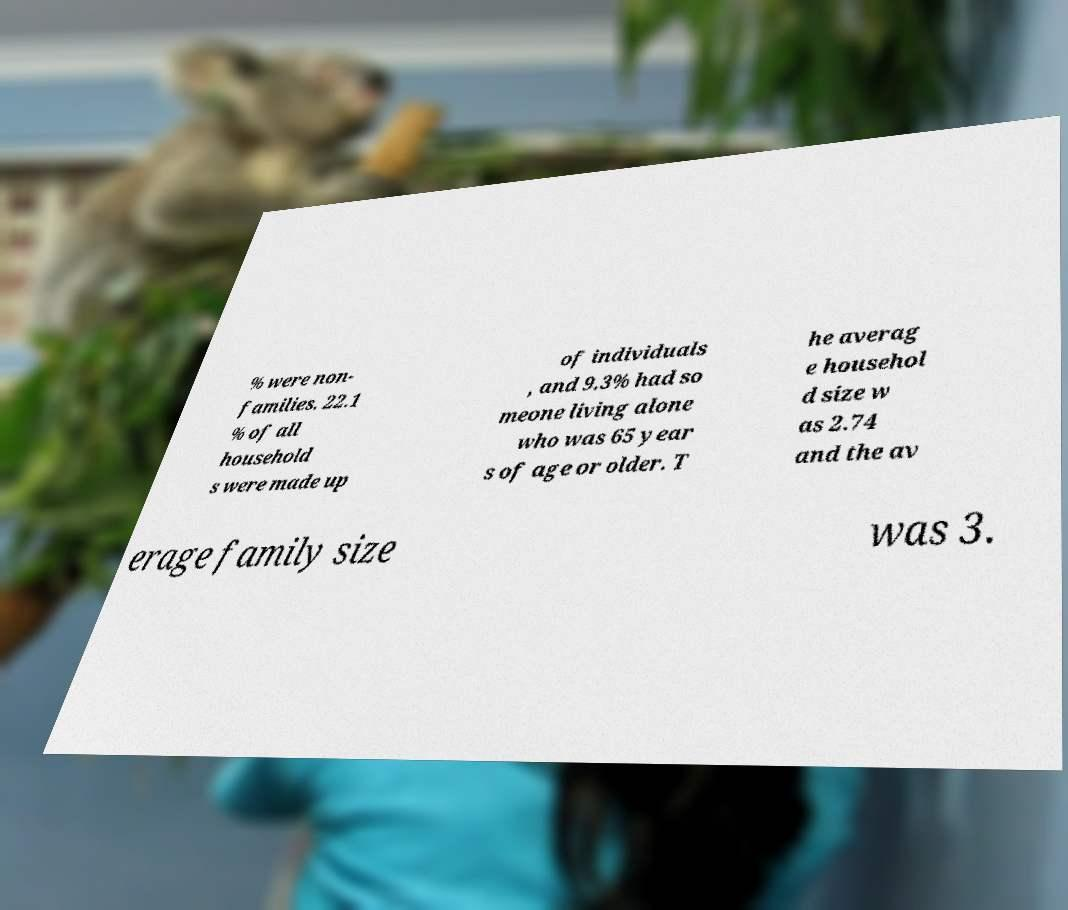Can you accurately transcribe the text from the provided image for me? % were non- families. 22.1 % of all household s were made up of individuals , and 9.3% had so meone living alone who was 65 year s of age or older. T he averag e househol d size w as 2.74 and the av erage family size was 3. 